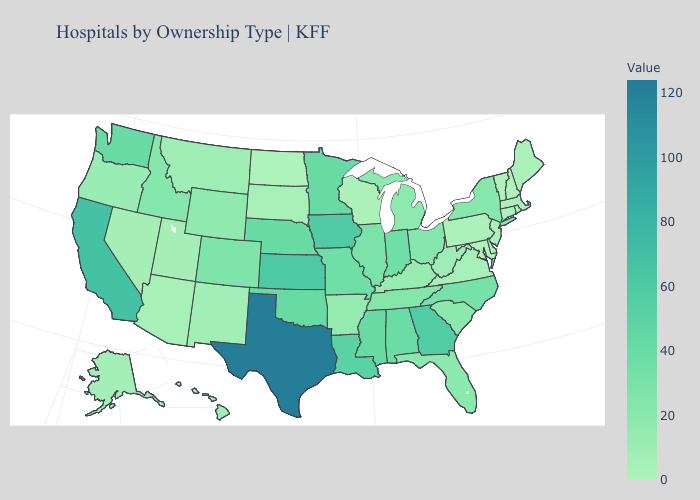Which states have the highest value in the USA?
Give a very brief answer. Texas. Does North Carolina have a higher value than California?
Answer briefly. No. Does Maryland have a higher value than Iowa?
Short answer required. No. Does New Hampshire have the highest value in the Northeast?
Answer briefly. No. Is the legend a continuous bar?
Short answer required. Yes. Among the states that border Texas , which have the lowest value?
Quick response, please. New Mexico. Does Texas have the highest value in the USA?
Give a very brief answer. Yes. 